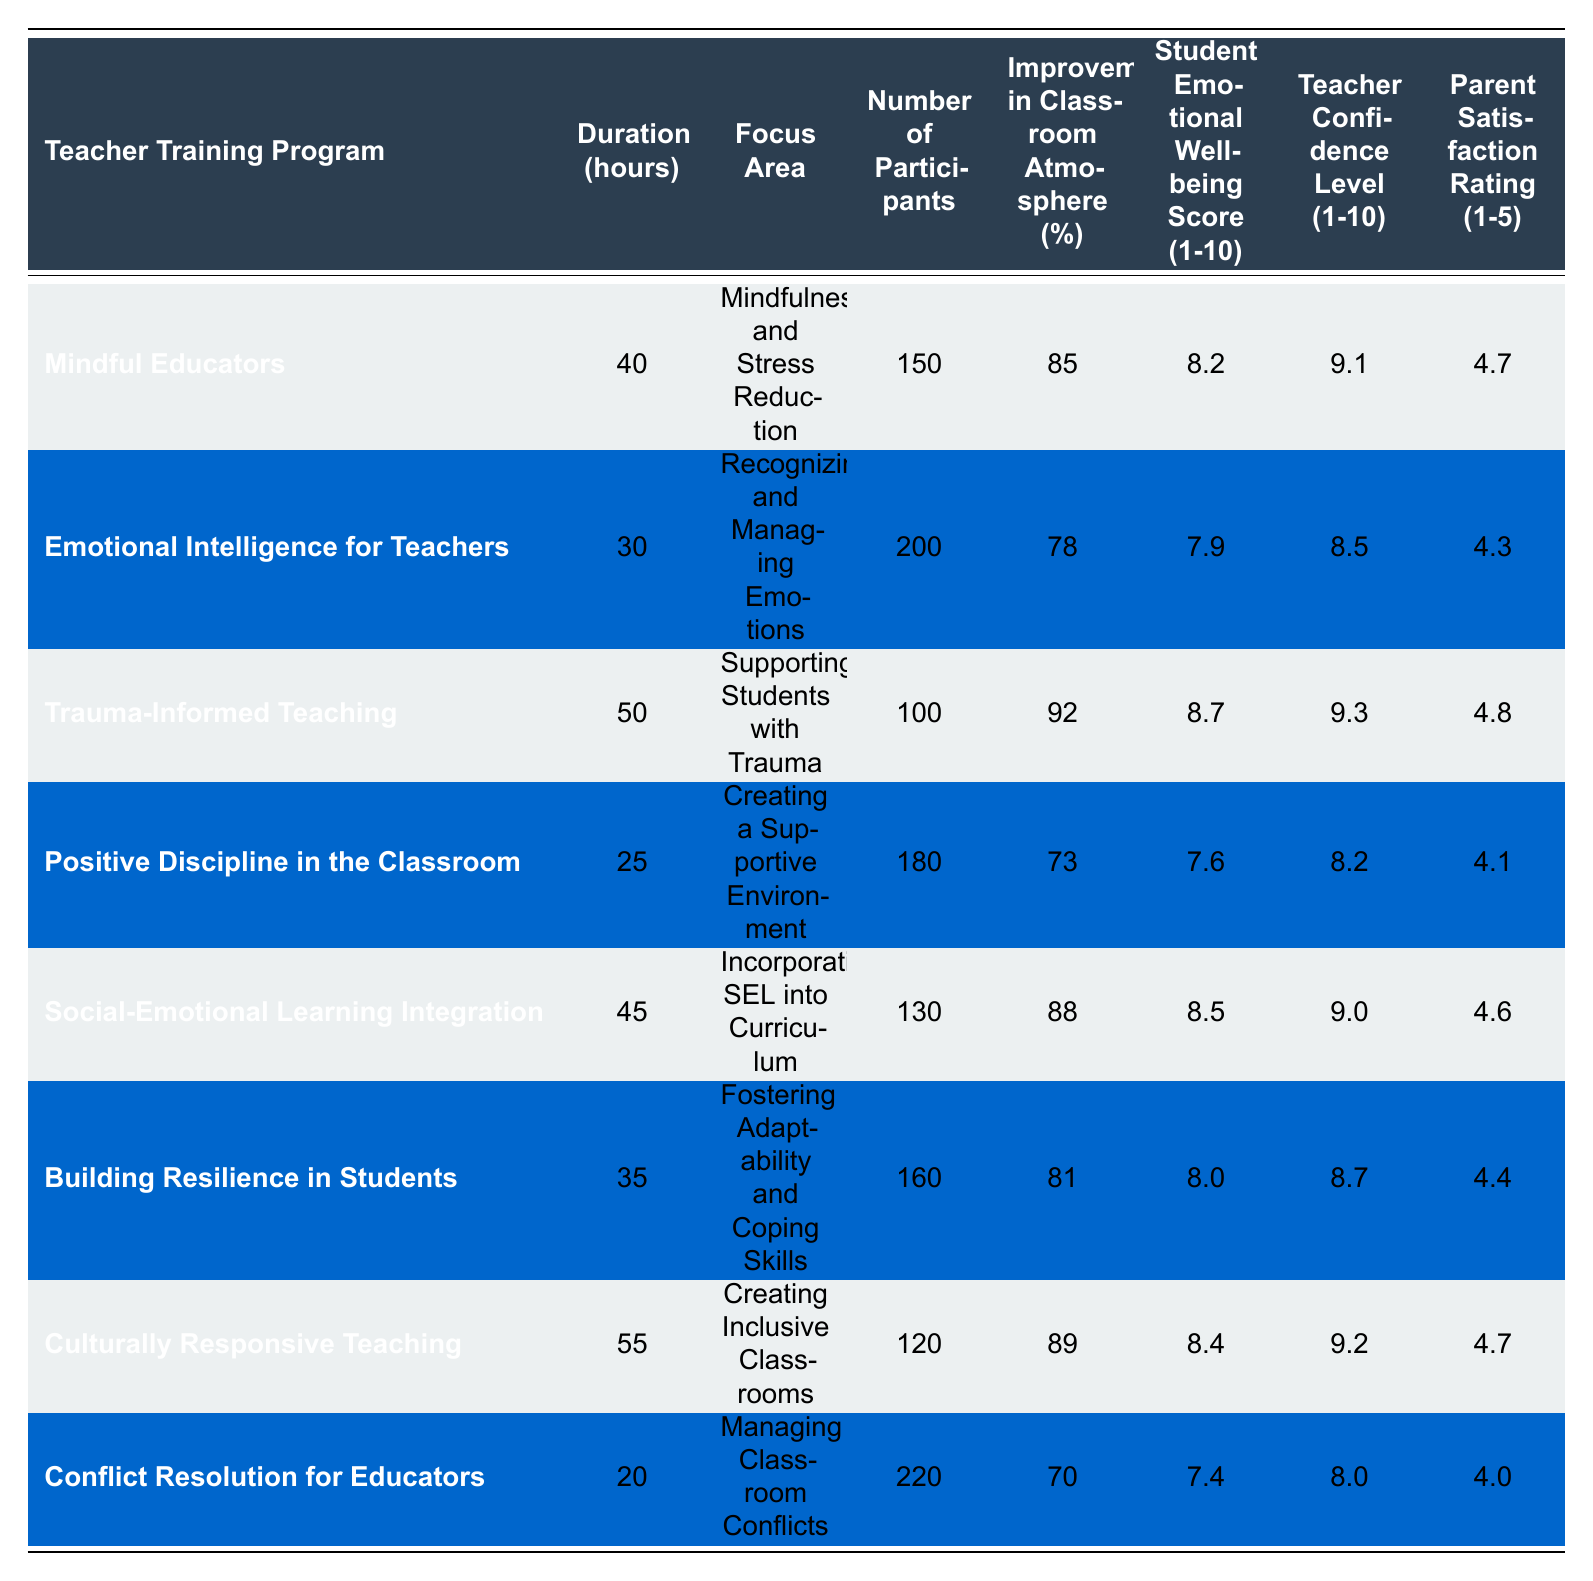What is the highest improvement percentage in classroom atmosphere? The table shows the improvement percentages for each program. The highest value is 92% from the "Trauma-Informed Teaching" program.
Answer: 92% Which teacher training program had the most participants? By examining the "Number of Participants" column, "Conflict Resolution for Educators" has the highest number, which is 220 participants.
Answer: 220 What is the average Student Emotional Well-being Score for all programs? Adding the scores: (8.2 + 7.9 + 8.7 + 7.6 + 8.5 + 8.0 + 8.4 + 7.4) = 57.7. There are 8 programs, so the average is 57.7 / 8 = 7.2125, which rounds to 7.21.
Answer: 7.21 Is there a teacher training program that scored below 75% in improvement of classroom atmosphere? Looking at the "Improvement in Classroom Atmosphere (%)" column, "Positive Discipline in the Classroom" (73%) and "Conflict Resolution for Educators" (70%) both fall below 75%.
Answer: Yes What is the difference in Parent Satisfaction Rating between the highest and lowest rating programs? The highest rating is 4.8 for "Trauma-Informed Teaching" and the lowest is 4.0 for "Conflict Resolution for Educators." The difference is 4.8 - 4.0 = 0.8.
Answer: 0.8 Which program has the highest Teacher Confidence Level and how does it compare to the lowest? "Trauma-Informed Teaching" has the highest Teacher Confidence Level at 9.3, and "Conflict Resolution for Educators" has the lowest at 8.0. The difference is 9.3 - 8.0 = 1.3.
Answer: 1.3 How many programs focus on "Creating Inclusive Classrooms"? "Culturally Responsive Teaching" is the only program that focuses on "Creating Inclusive Classrooms," so the answer is 1.
Answer: 1 What is the overall trend in the relationship between Teacher Confidence Level and Improvement in Classroom Atmosphere? Looking at the table, programs with higher Teacher Confidence Levels, such as "Trauma-Informed Teaching" (9.3 with 92% improvement), tend to have higher improvement percentages, suggesting a positive correlation.
Answer: Positive correlation Which programs are above the average in Student Emotional Well-being Score? The average score is 7.21. The programs "Mindful Educators" (8.2), "Trauma-Informed Teaching" (8.7), "Social-Emotional Learning Integration" (8.5), "Culturally Responsive Teaching" (8.4), and "Building Resilience in Students" (8.0) are above average.
Answer: 5 programs What is the relationship between the duration of the training programs and Parent Satisfaction Rating? When comparing the table data, programs with lower duration like "Conflict Resolution for Educators" (20 hours) have the lowest Parent Satisfaction Rating (4.0), while longer durations like "Trauma-Informed Teaching" (50 hours) are associated with higher ratings (4.8).
Answer: Negative trend 